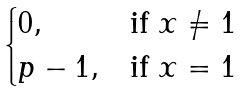Convert formula to latex. <formula><loc_0><loc_0><loc_500><loc_500>\begin{cases} 0 , & \text {if } x \neq 1 \\ p - 1 , & \text {if } x = 1 \\ \end{cases}</formula> 